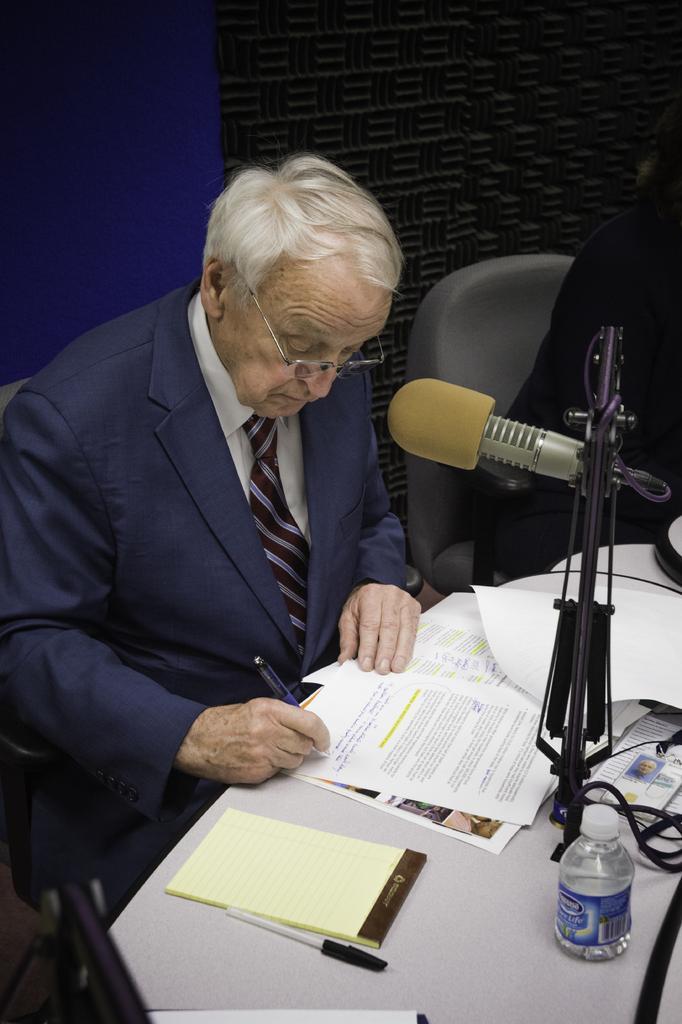Could you give a brief overview of what you see in this image? In this picture we can see two persons. There is a man sitting on the chair and writing on the paper. There is a table. On the table we can see a book, bottle, papers, pen, and a mike. In the background there is a wall. 